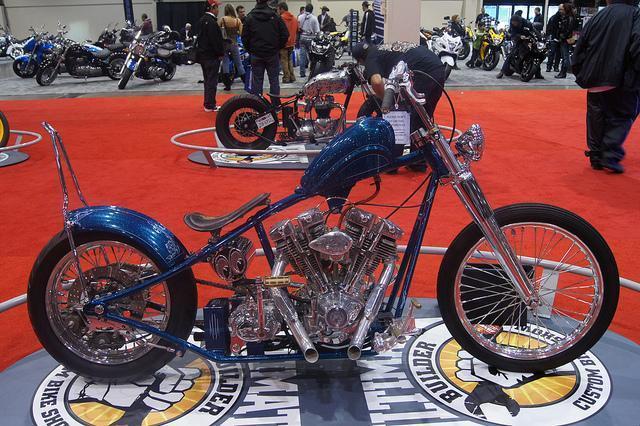How many motorcycles are in the picture?
Give a very brief answer. 4. How many people are there?
Give a very brief answer. 5. How many elephant is there?
Give a very brief answer. 0. 